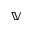Convert formula to latex. <formula><loc_0><loc_0><loc_500><loc_500>\mathbb { V }</formula> 